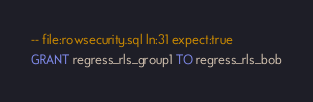<code> <loc_0><loc_0><loc_500><loc_500><_SQL_>-- file:rowsecurity.sql ln:31 expect:true
GRANT regress_rls_group1 TO regress_rls_bob
</code> 